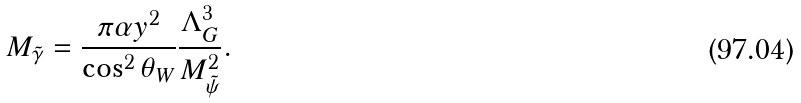<formula> <loc_0><loc_0><loc_500><loc_500>M _ { \tilde { \gamma } } = \frac { \pi \alpha y ^ { 2 } } { \cos ^ { 2 } \theta _ { W } } \frac { \Lambda _ { G } ^ { 3 } } { M ^ { 2 } _ { \tilde { \psi } } } .</formula> 